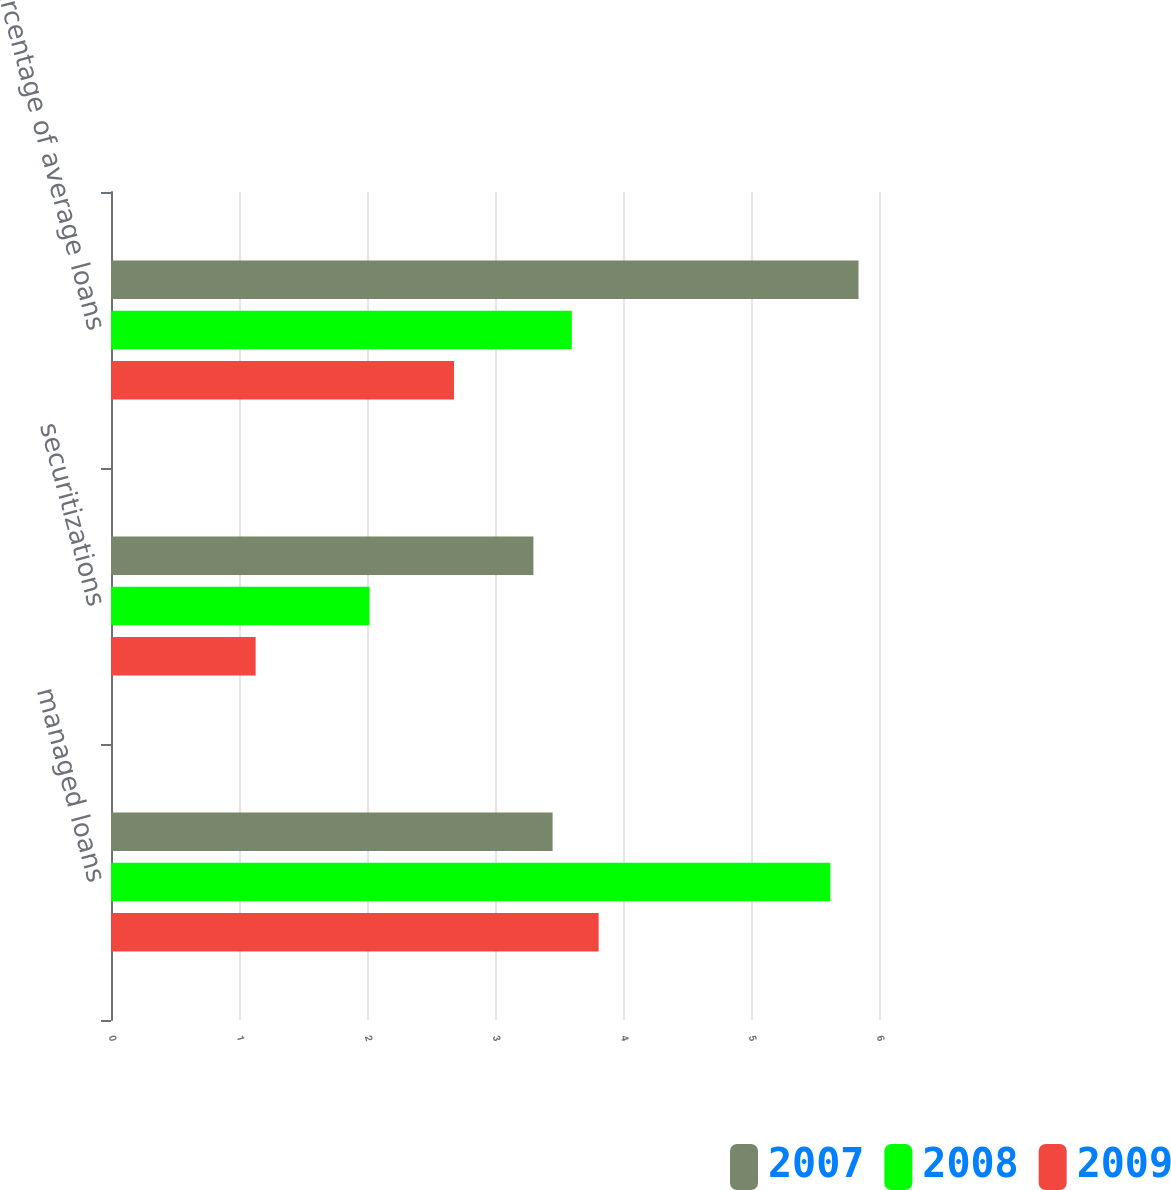<chart> <loc_0><loc_0><loc_500><loc_500><stacked_bar_chart><ecel><fcel>managed loans<fcel>securitizations<fcel>percentage of average loans<nl><fcel>2007<fcel>3.45<fcel>3.3<fcel>5.84<nl><fcel>2008<fcel>5.62<fcel>2.02<fcel>3.6<nl><fcel>2009<fcel>3.81<fcel>1.13<fcel>2.68<nl></chart> 